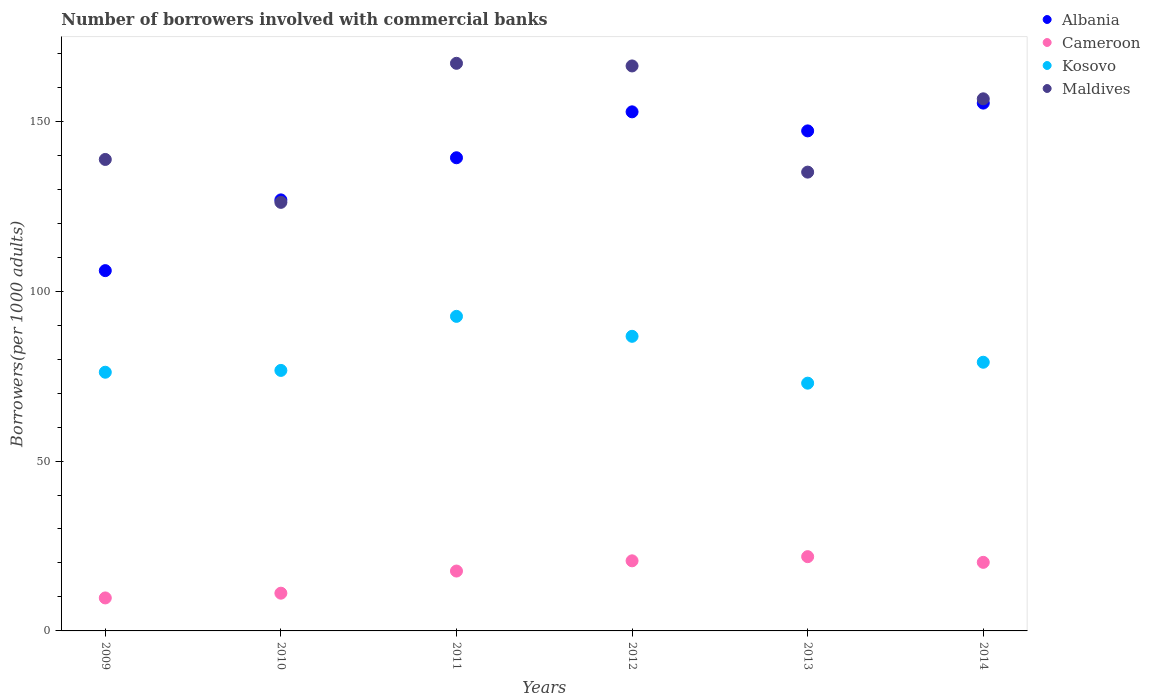Is the number of dotlines equal to the number of legend labels?
Make the answer very short. Yes. What is the number of borrowers involved with commercial banks in Kosovo in 2010?
Keep it short and to the point. 76.67. Across all years, what is the maximum number of borrowers involved with commercial banks in Kosovo?
Offer a very short reply. 92.59. Across all years, what is the minimum number of borrowers involved with commercial banks in Albania?
Keep it short and to the point. 106.05. In which year was the number of borrowers involved with commercial banks in Maldives maximum?
Keep it short and to the point. 2011. What is the total number of borrowers involved with commercial banks in Albania in the graph?
Offer a terse response. 827.49. What is the difference between the number of borrowers involved with commercial banks in Albania in 2009 and that in 2012?
Give a very brief answer. -46.73. What is the difference between the number of borrowers involved with commercial banks in Maldives in 2010 and the number of borrowers involved with commercial banks in Cameroon in 2009?
Make the answer very short. 116.43. What is the average number of borrowers involved with commercial banks in Maldives per year?
Your response must be concise. 148.32. In the year 2011, what is the difference between the number of borrowers involved with commercial banks in Albania and number of borrowers involved with commercial banks in Kosovo?
Your answer should be compact. 46.68. In how many years, is the number of borrowers involved with commercial banks in Cameroon greater than 60?
Ensure brevity in your answer.  0. What is the ratio of the number of borrowers involved with commercial banks in Kosovo in 2009 to that in 2010?
Offer a terse response. 0.99. What is the difference between the highest and the second highest number of borrowers involved with commercial banks in Cameroon?
Give a very brief answer. 1.23. What is the difference between the highest and the lowest number of borrowers involved with commercial banks in Albania?
Make the answer very short. 49.31. In how many years, is the number of borrowers involved with commercial banks in Albania greater than the average number of borrowers involved with commercial banks in Albania taken over all years?
Keep it short and to the point. 4. Is the sum of the number of borrowers involved with commercial banks in Cameroon in 2009 and 2014 greater than the maximum number of borrowers involved with commercial banks in Maldives across all years?
Your answer should be very brief. No. Is the number of borrowers involved with commercial banks in Maldives strictly less than the number of borrowers involved with commercial banks in Cameroon over the years?
Offer a terse response. No. What is the difference between two consecutive major ticks on the Y-axis?
Offer a terse response. 50. Does the graph contain grids?
Provide a succinct answer. No. Where does the legend appear in the graph?
Offer a very short reply. Top right. What is the title of the graph?
Make the answer very short. Number of borrowers involved with commercial banks. What is the label or title of the Y-axis?
Offer a very short reply. Borrowers(per 1000 adults). What is the Borrowers(per 1000 adults) in Albania in 2009?
Provide a succinct answer. 106.05. What is the Borrowers(per 1000 adults) of Cameroon in 2009?
Ensure brevity in your answer.  9.71. What is the Borrowers(per 1000 adults) in Kosovo in 2009?
Ensure brevity in your answer.  76.14. What is the Borrowers(per 1000 adults) in Maldives in 2009?
Give a very brief answer. 138.77. What is the Borrowers(per 1000 adults) of Albania in 2010?
Give a very brief answer. 126.87. What is the Borrowers(per 1000 adults) in Cameroon in 2010?
Provide a succinct answer. 11.11. What is the Borrowers(per 1000 adults) in Kosovo in 2010?
Give a very brief answer. 76.67. What is the Borrowers(per 1000 adults) in Maldives in 2010?
Provide a succinct answer. 126.14. What is the Borrowers(per 1000 adults) of Albania in 2011?
Provide a succinct answer. 139.27. What is the Borrowers(per 1000 adults) in Cameroon in 2011?
Provide a succinct answer. 17.62. What is the Borrowers(per 1000 adults) in Kosovo in 2011?
Offer a terse response. 92.59. What is the Borrowers(per 1000 adults) of Maldives in 2011?
Offer a very short reply. 167.07. What is the Borrowers(per 1000 adults) of Albania in 2012?
Your answer should be compact. 152.78. What is the Borrowers(per 1000 adults) of Cameroon in 2012?
Make the answer very short. 20.63. What is the Borrowers(per 1000 adults) in Kosovo in 2012?
Offer a very short reply. 86.71. What is the Borrowers(per 1000 adults) of Maldives in 2012?
Offer a terse response. 166.29. What is the Borrowers(per 1000 adults) of Albania in 2013?
Offer a very short reply. 147.17. What is the Borrowers(per 1000 adults) in Cameroon in 2013?
Give a very brief answer. 21.86. What is the Borrowers(per 1000 adults) in Kosovo in 2013?
Offer a terse response. 72.92. What is the Borrowers(per 1000 adults) in Maldives in 2013?
Make the answer very short. 135.04. What is the Borrowers(per 1000 adults) in Albania in 2014?
Your response must be concise. 155.35. What is the Borrowers(per 1000 adults) of Cameroon in 2014?
Your response must be concise. 20.18. What is the Borrowers(per 1000 adults) of Kosovo in 2014?
Give a very brief answer. 79.08. What is the Borrowers(per 1000 adults) in Maldives in 2014?
Offer a terse response. 156.61. Across all years, what is the maximum Borrowers(per 1000 adults) of Albania?
Offer a very short reply. 155.35. Across all years, what is the maximum Borrowers(per 1000 adults) in Cameroon?
Make the answer very short. 21.86. Across all years, what is the maximum Borrowers(per 1000 adults) of Kosovo?
Provide a short and direct response. 92.59. Across all years, what is the maximum Borrowers(per 1000 adults) of Maldives?
Keep it short and to the point. 167.07. Across all years, what is the minimum Borrowers(per 1000 adults) of Albania?
Your response must be concise. 106.05. Across all years, what is the minimum Borrowers(per 1000 adults) of Cameroon?
Offer a very short reply. 9.71. Across all years, what is the minimum Borrowers(per 1000 adults) in Kosovo?
Your response must be concise. 72.92. Across all years, what is the minimum Borrowers(per 1000 adults) of Maldives?
Make the answer very short. 126.14. What is the total Borrowers(per 1000 adults) of Albania in the graph?
Give a very brief answer. 827.49. What is the total Borrowers(per 1000 adults) of Cameroon in the graph?
Give a very brief answer. 101.11. What is the total Borrowers(per 1000 adults) in Kosovo in the graph?
Give a very brief answer. 484.12. What is the total Borrowers(per 1000 adults) in Maldives in the graph?
Give a very brief answer. 889.91. What is the difference between the Borrowers(per 1000 adults) of Albania in 2009 and that in 2010?
Provide a short and direct response. -20.82. What is the difference between the Borrowers(per 1000 adults) of Cameroon in 2009 and that in 2010?
Ensure brevity in your answer.  -1.4. What is the difference between the Borrowers(per 1000 adults) in Kosovo in 2009 and that in 2010?
Provide a short and direct response. -0.53. What is the difference between the Borrowers(per 1000 adults) in Maldives in 2009 and that in 2010?
Offer a terse response. 12.63. What is the difference between the Borrowers(per 1000 adults) of Albania in 2009 and that in 2011?
Keep it short and to the point. -33.22. What is the difference between the Borrowers(per 1000 adults) in Cameroon in 2009 and that in 2011?
Provide a succinct answer. -7.91. What is the difference between the Borrowers(per 1000 adults) in Kosovo in 2009 and that in 2011?
Provide a succinct answer. -16.44. What is the difference between the Borrowers(per 1000 adults) of Maldives in 2009 and that in 2011?
Give a very brief answer. -28.3. What is the difference between the Borrowers(per 1000 adults) in Albania in 2009 and that in 2012?
Offer a very short reply. -46.73. What is the difference between the Borrowers(per 1000 adults) in Cameroon in 2009 and that in 2012?
Give a very brief answer. -10.92. What is the difference between the Borrowers(per 1000 adults) of Kosovo in 2009 and that in 2012?
Keep it short and to the point. -10.57. What is the difference between the Borrowers(per 1000 adults) of Maldives in 2009 and that in 2012?
Offer a terse response. -27.52. What is the difference between the Borrowers(per 1000 adults) of Albania in 2009 and that in 2013?
Give a very brief answer. -41.13. What is the difference between the Borrowers(per 1000 adults) in Cameroon in 2009 and that in 2013?
Your response must be concise. -12.15. What is the difference between the Borrowers(per 1000 adults) of Kosovo in 2009 and that in 2013?
Provide a short and direct response. 3.22. What is the difference between the Borrowers(per 1000 adults) in Maldives in 2009 and that in 2013?
Offer a terse response. 3.73. What is the difference between the Borrowers(per 1000 adults) of Albania in 2009 and that in 2014?
Your answer should be compact. -49.31. What is the difference between the Borrowers(per 1000 adults) of Cameroon in 2009 and that in 2014?
Your answer should be very brief. -10.47. What is the difference between the Borrowers(per 1000 adults) of Kosovo in 2009 and that in 2014?
Make the answer very short. -2.94. What is the difference between the Borrowers(per 1000 adults) of Maldives in 2009 and that in 2014?
Your response must be concise. -17.85. What is the difference between the Borrowers(per 1000 adults) in Albania in 2010 and that in 2011?
Give a very brief answer. -12.4. What is the difference between the Borrowers(per 1000 adults) of Cameroon in 2010 and that in 2011?
Make the answer very short. -6.52. What is the difference between the Borrowers(per 1000 adults) in Kosovo in 2010 and that in 2011?
Provide a short and direct response. -15.91. What is the difference between the Borrowers(per 1000 adults) in Maldives in 2010 and that in 2011?
Offer a very short reply. -40.93. What is the difference between the Borrowers(per 1000 adults) of Albania in 2010 and that in 2012?
Your answer should be compact. -25.91. What is the difference between the Borrowers(per 1000 adults) in Cameroon in 2010 and that in 2012?
Make the answer very short. -9.53. What is the difference between the Borrowers(per 1000 adults) of Kosovo in 2010 and that in 2012?
Your answer should be very brief. -10.04. What is the difference between the Borrowers(per 1000 adults) in Maldives in 2010 and that in 2012?
Give a very brief answer. -40.15. What is the difference between the Borrowers(per 1000 adults) in Albania in 2010 and that in 2013?
Your answer should be compact. -20.31. What is the difference between the Borrowers(per 1000 adults) of Cameroon in 2010 and that in 2013?
Give a very brief answer. -10.75. What is the difference between the Borrowers(per 1000 adults) of Kosovo in 2010 and that in 2013?
Provide a short and direct response. 3.75. What is the difference between the Borrowers(per 1000 adults) in Maldives in 2010 and that in 2013?
Your answer should be compact. -8.9. What is the difference between the Borrowers(per 1000 adults) in Albania in 2010 and that in 2014?
Ensure brevity in your answer.  -28.49. What is the difference between the Borrowers(per 1000 adults) of Cameroon in 2010 and that in 2014?
Offer a very short reply. -9.08. What is the difference between the Borrowers(per 1000 adults) of Kosovo in 2010 and that in 2014?
Offer a terse response. -2.41. What is the difference between the Borrowers(per 1000 adults) in Maldives in 2010 and that in 2014?
Provide a succinct answer. -30.48. What is the difference between the Borrowers(per 1000 adults) of Albania in 2011 and that in 2012?
Your answer should be compact. -13.51. What is the difference between the Borrowers(per 1000 adults) of Cameroon in 2011 and that in 2012?
Your answer should be very brief. -3.01. What is the difference between the Borrowers(per 1000 adults) of Kosovo in 2011 and that in 2012?
Make the answer very short. 5.87. What is the difference between the Borrowers(per 1000 adults) in Maldives in 2011 and that in 2012?
Your response must be concise. 0.78. What is the difference between the Borrowers(per 1000 adults) in Albania in 2011 and that in 2013?
Provide a short and direct response. -7.91. What is the difference between the Borrowers(per 1000 adults) of Cameroon in 2011 and that in 2013?
Keep it short and to the point. -4.23. What is the difference between the Borrowers(per 1000 adults) of Kosovo in 2011 and that in 2013?
Your answer should be compact. 19.66. What is the difference between the Borrowers(per 1000 adults) of Maldives in 2011 and that in 2013?
Provide a succinct answer. 32.03. What is the difference between the Borrowers(per 1000 adults) in Albania in 2011 and that in 2014?
Offer a very short reply. -16.09. What is the difference between the Borrowers(per 1000 adults) in Cameroon in 2011 and that in 2014?
Provide a succinct answer. -2.56. What is the difference between the Borrowers(per 1000 adults) of Kosovo in 2011 and that in 2014?
Ensure brevity in your answer.  13.5. What is the difference between the Borrowers(per 1000 adults) in Maldives in 2011 and that in 2014?
Offer a very short reply. 10.45. What is the difference between the Borrowers(per 1000 adults) of Albania in 2012 and that in 2013?
Provide a succinct answer. 5.61. What is the difference between the Borrowers(per 1000 adults) in Cameroon in 2012 and that in 2013?
Offer a terse response. -1.23. What is the difference between the Borrowers(per 1000 adults) of Kosovo in 2012 and that in 2013?
Ensure brevity in your answer.  13.79. What is the difference between the Borrowers(per 1000 adults) in Maldives in 2012 and that in 2013?
Your answer should be compact. 31.25. What is the difference between the Borrowers(per 1000 adults) of Albania in 2012 and that in 2014?
Keep it short and to the point. -2.57. What is the difference between the Borrowers(per 1000 adults) of Cameroon in 2012 and that in 2014?
Offer a very short reply. 0.45. What is the difference between the Borrowers(per 1000 adults) in Kosovo in 2012 and that in 2014?
Your answer should be compact. 7.63. What is the difference between the Borrowers(per 1000 adults) in Maldives in 2012 and that in 2014?
Make the answer very short. 9.68. What is the difference between the Borrowers(per 1000 adults) of Albania in 2013 and that in 2014?
Your answer should be very brief. -8.18. What is the difference between the Borrowers(per 1000 adults) in Cameroon in 2013 and that in 2014?
Offer a terse response. 1.68. What is the difference between the Borrowers(per 1000 adults) of Kosovo in 2013 and that in 2014?
Offer a terse response. -6.16. What is the difference between the Borrowers(per 1000 adults) in Maldives in 2013 and that in 2014?
Offer a very short reply. -21.58. What is the difference between the Borrowers(per 1000 adults) in Albania in 2009 and the Borrowers(per 1000 adults) in Cameroon in 2010?
Your response must be concise. 94.94. What is the difference between the Borrowers(per 1000 adults) of Albania in 2009 and the Borrowers(per 1000 adults) of Kosovo in 2010?
Offer a very short reply. 29.37. What is the difference between the Borrowers(per 1000 adults) of Albania in 2009 and the Borrowers(per 1000 adults) of Maldives in 2010?
Offer a terse response. -20.09. What is the difference between the Borrowers(per 1000 adults) of Cameroon in 2009 and the Borrowers(per 1000 adults) of Kosovo in 2010?
Make the answer very short. -66.96. What is the difference between the Borrowers(per 1000 adults) of Cameroon in 2009 and the Borrowers(per 1000 adults) of Maldives in 2010?
Offer a very short reply. -116.43. What is the difference between the Borrowers(per 1000 adults) of Kosovo in 2009 and the Borrowers(per 1000 adults) of Maldives in 2010?
Give a very brief answer. -50. What is the difference between the Borrowers(per 1000 adults) in Albania in 2009 and the Borrowers(per 1000 adults) in Cameroon in 2011?
Offer a terse response. 88.42. What is the difference between the Borrowers(per 1000 adults) of Albania in 2009 and the Borrowers(per 1000 adults) of Kosovo in 2011?
Ensure brevity in your answer.  13.46. What is the difference between the Borrowers(per 1000 adults) in Albania in 2009 and the Borrowers(per 1000 adults) in Maldives in 2011?
Your answer should be very brief. -61.02. What is the difference between the Borrowers(per 1000 adults) of Cameroon in 2009 and the Borrowers(per 1000 adults) of Kosovo in 2011?
Your response must be concise. -82.88. What is the difference between the Borrowers(per 1000 adults) of Cameroon in 2009 and the Borrowers(per 1000 adults) of Maldives in 2011?
Your answer should be very brief. -157.36. What is the difference between the Borrowers(per 1000 adults) of Kosovo in 2009 and the Borrowers(per 1000 adults) of Maldives in 2011?
Offer a very short reply. -90.93. What is the difference between the Borrowers(per 1000 adults) in Albania in 2009 and the Borrowers(per 1000 adults) in Cameroon in 2012?
Offer a terse response. 85.42. What is the difference between the Borrowers(per 1000 adults) in Albania in 2009 and the Borrowers(per 1000 adults) in Kosovo in 2012?
Your answer should be very brief. 19.33. What is the difference between the Borrowers(per 1000 adults) of Albania in 2009 and the Borrowers(per 1000 adults) of Maldives in 2012?
Offer a very short reply. -60.24. What is the difference between the Borrowers(per 1000 adults) in Cameroon in 2009 and the Borrowers(per 1000 adults) in Kosovo in 2012?
Ensure brevity in your answer.  -77. What is the difference between the Borrowers(per 1000 adults) in Cameroon in 2009 and the Borrowers(per 1000 adults) in Maldives in 2012?
Provide a short and direct response. -156.58. What is the difference between the Borrowers(per 1000 adults) of Kosovo in 2009 and the Borrowers(per 1000 adults) of Maldives in 2012?
Offer a very short reply. -90.15. What is the difference between the Borrowers(per 1000 adults) in Albania in 2009 and the Borrowers(per 1000 adults) in Cameroon in 2013?
Ensure brevity in your answer.  84.19. What is the difference between the Borrowers(per 1000 adults) in Albania in 2009 and the Borrowers(per 1000 adults) in Kosovo in 2013?
Your answer should be very brief. 33.12. What is the difference between the Borrowers(per 1000 adults) of Albania in 2009 and the Borrowers(per 1000 adults) of Maldives in 2013?
Your answer should be very brief. -28.99. What is the difference between the Borrowers(per 1000 adults) of Cameroon in 2009 and the Borrowers(per 1000 adults) of Kosovo in 2013?
Ensure brevity in your answer.  -63.21. What is the difference between the Borrowers(per 1000 adults) of Cameroon in 2009 and the Borrowers(per 1000 adults) of Maldives in 2013?
Your answer should be very brief. -125.33. What is the difference between the Borrowers(per 1000 adults) of Kosovo in 2009 and the Borrowers(per 1000 adults) of Maldives in 2013?
Your answer should be compact. -58.9. What is the difference between the Borrowers(per 1000 adults) in Albania in 2009 and the Borrowers(per 1000 adults) in Cameroon in 2014?
Offer a very short reply. 85.86. What is the difference between the Borrowers(per 1000 adults) of Albania in 2009 and the Borrowers(per 1000 adults) of Kosovo in 2014?
Offer a very short reply. 26.96. What is the difference between the Borrowers(per 1000 adults) in Albania in 2009 and the Borrowers(per 1000 adults) in Maldives in 2014?
Your answer should be compact. -50.57. What is the difference between the Borrowers(per 1000 adults) of Cameroon in 2009 and the Borrowers(per 1000 adults) of Kosovo in 2014?
Your answer should be very brief. -69.37. What is the difference between the Borrowers(per 1000 adults) in Cameroon in 2009 and the Borrowers(per 1000 adults) in Maldives in 2014?
Ensure brevity in your answer.  -146.9. What is the difference between the Borrowers(per 1000 adults) of Kosovo in 2009 and the Borrowers(per 1000 adults) of Maldives in 2014?
Make the answer very short. -80.47. What is the difference between the Borrowers(per 1000 adults) of Albania in 2010 and the Borrowers(per 1000 adults) of Cameroon in 2011?
Give a very brief answer. 109.24. What is the difference between the Borrowers(per 1000 adults) of Albania in 2010 and the Borrowers(per 1000 adults) of Kosovo in 2011?
Keep it short and to the point. 34.28. What is the difference between the Borrowers(per 1000 adults) of Albania in 2010 and the Borrowers(per 1000 adults) of Maldives in 2011?
Offer a terse response. -40.2. What is the difference between the Borrowers(per 1000 adults) in Cameroon in 2010 and the Borrowers(per 1000 adults) in Kosovo in 2011?
Offer a terse response. -81.48. What is the difference between the Borrowers(per 1000 adults) of Cameroon in 2010 and the Borrowers(per 1000 adults) of Maldives in 2011?
Make the answer very short. -155.96. What is the difference between the Borrowers(per 1000 adults) in Kosovo in 2010 and the Borrowers(per 1000 adults) in Maldives in 2011?
Make the answer very short. -90.39. What is the difference between the Borrowers(per 1000 adults) of Albania in 2010 and the Borrowers(per 1000 adults) of Cameroon in 2012?
Your answer should be compact. 106.24. What is the difference between the Borrowers(per 1000 adults) in Albania in 2010 and the Borrowers(per 1000 adults) in Kosovo in 2012?
Make the answer very short. 40.16. What is the difference between the Borrowers(per 1000 adults) in Albania in 2010 and the Borrowers(per 1000 adults) in Maldives in 2012?
Keep it short and to the point. -39.42. What is the difference between the Borrowers(per 1000 adults) of Cameroon in 2010 and the Borrowers(per 1000 adults) of Kosovo in 2012?
Offer a very short reply. -75.61. What is the difference between the Borrowers(per 1000 adults) of Cameroon in 2010 and the Borrowers(per 1000 adults) of Maldives in 2012?
Make the answer very short. -155.18. What is the difference between the Borrowers(per 1000 adults) in Kosovo in 2010 and the Borrowers(per 1000 adults) in Maldives in 2012?
Keep it short and to the point. -89.62. What is the difference between the Borrowers(per 1000 adults) of Albania in 2010 and the Borrowers(per 1000 adults) of Cameroon in 2013?
Ensure brevity in your answer.  105.01. What is the difference between the Borrowers(per 1000 adults) of Albania in 2010 and the Borrowers(per 1000 adults) of Kosovo in 2013?
Keep it short and to the point. 53.95. What is the difference between the Borrowers(per 1000 adults) in Albania in 2010 and the Borrowers(per 1000 adults) in Maldives in 2013?
Provide a succinct answer. -8.17. What is the difference between the Borrowers(per 1000 adults) of Cameroon in 2010 and the Borrowers(per 1000 adults) of Kosovo in 2013?
Make the answer very short. -61.82. What is the difference between the Borrowers(per 1000 adults) of Cameroon in 2010 and the Borrowers(per 1000 adults) of Maldives in 2013?
Offer a very short reply. -123.93. What is the difference between the Borrowers(per 1000 adults) in Kosovo in 2010 and the Borrowers(per 1000 adults) in Maldives in 2013?
Make the answer very short. -58.36. What is the difference between the Borrowers(per 1000 adults) of Albania in 2010 and the Borrowers(per 1000 adults) of Cameroon in 2014?
Your answer should be very brief. 106.69. What is the difference between the Borrowers(per 1000 adults) in Albania in 2010 and the Borrowers(per 1000 adults) in Kosovo in 2014?
Ensure brevity in your answer.  47.79. What is the difference between the Borrowers(per 1000 adults) in Albania in 2010 and the Borrowers(per 1000 adults) in Maldives in 2014?
Make the answer very short. -29.75. What is the difference between the Borrowers(per 1000 adults) of Cameroon in 2010 and the Borrowers(per 1000 adults) of Kosovo in 2014?
Make the answer very short. -67.98. What is the difference between the Borrowers(per 1000 adults) of Cameroon in 2010 and the Borrowers(per 1000 adults) of Maldives in 2014?
Provide a short and direct response. -145.51. What is the difference between the Borrowers(per 1000 adults) in Kosovo in 2010 and the Borrowers(per 1000 adults) in Maldives in 2014?
Give a very brief answer. -79.94. What is the difference between the Borrowers(per 1000 adults) of Albania in 2011 and the Borrowers(per 1000 adults) of Cameroon in 2012?
Make the answer very short. 118.64. What is the difference between the Borrowers(per 1000 adults) in Albania in 2011 and the Borrowers(per 1000 adults) in Kosovo in 2012?
Ensure brevity in your answer.  52.55. What is the difference between the Borrowers(per 1000 adults) in Albania in 2011 and the Borrowers(per 1000 adults) in Maldives in 2012?
Provide a short and direct response. -27.02. What is the difference between the Borrowers(per 1000 adults) in Cameroon in 2011 and the Borrowers(per 1000 adults) in Kosovo in 2012?
Give a very brief answer. -69.09. What is the difference between the Borrowers(per 1000 adults) of Cameroon in 2011 and the Borrowers(per 1000 adults) of Maldives in 2012?
Provide a short and direct response. -148.67. What is the difference between the Borrowers(per 1000 adults) of Kosovo in 2011 and the Borrowers(per 1000 adults) of Maldives in 2012?
Make the answer very short. -73.7. What is the difference between the Borrowers(per 1000 adults) in Albania in 2011 and the Borrowers(per 1000 adults) in Cameroon in 2013?
Keep it short and to the point. 117.41. What is the difference between the Borrowers(per 1000 adults) of Albania in 2011 and the Borrowers(per 1000 adults) of Kosovo in 2013?
Offer a very short reply. 66.34. What is the difference between the Borrowers(per 1000 adults) in Albania in 2011 and the Borrowers(per 1000 adults) in Maldives in 2013?
Offer a terse response. 4.23. What is the difference between the Borrowers(per 1000 adults) of Cameroon in 2011 and the Borrowers(per 1000 adults) of Kosovo in 2013?
Offer a very short reply. -55.3. What is the difference between the Borrowers(per 1000 adults) of Cameroon in 2011 and the Borrowers(per 1000 adults) of Maldives in 2013?
Ensure brevity in your answer.  -117.41. What is the difference between the Borrowers(per 1000 adults) of Kosovo in 2011 and the Borrowers(per 1000 adults) of Maldives in 2013?
Provide a short and direct response. -42.45. What is the difference between the Borrowers(per 1000 adults) of Albania in 2011 and the Borrowers(per 1000 adults) of Cameroon in 2014?
Your answer should be compact. 119.08. What is the difference between the Borrowers(per 1000 adults) in Albania in 2011 and the Borrowers(per 1000 adults) in Kosovo in 2014?
Give a very brief answer. 60.19. What is the difference between the Borrowers(per 1000 adults) of Albania in 2011 and the Borrowers(per 1000 adults) of Maldives in 2014?
Make the answer very short. -17.35. What is the difference between the Borrowers(per 1000 adults) in Cameroon in 2011 and the Borrowers(per 1000 adults) in Kosovo in 2014?
Your answer should be compact. -61.46. What is the difference between the Borrowers(per 1000 adults) in Cameroon in 2011 and the Borrowers(per 1000 adults) in Maldives in 2014?
Make the answer very short. -138.99. What is the difference between the Borrowers(per 1000 adults) of Kosovo in 2011 and the Borrowers(per 1000 adults) of Maldives in 2014?
Make the answer very short. -64.03. What is the difference between the Borrowers(per 1000 adults) of Albania in 2012 and the Borrowers(per 1000 adults) of Cameroon in 2013?
Keep it short and to the point. 130.92. What is the difference between the Borrowers(per 1000 adults) of Albania in 2012 and the Borrowers(per 1000 adults) of Kosovo in 2013?
Offer a very short reply. 79.86. What is the difference between the Borrowers(per 1000 adults) of Albania in 2012 and the Borrowers(per 1000 adults) of Maldives in 2013?
Offer a very short reply. 17.74. What is the difference between the Borrowers(per 1000 adults) of Cameroon in 2012 and the Borrowers(per 1000 adults) of Kosovo in 2013?
Offer a very short reply. -52.29. What is the difference between the Borrowers(per 1000 adults) of Cameroon in 2012 and the Borrowers(per 1000 adults) of Maldives in 2013?
Provide a short and direct response. -114.41. What is the difference between the Borrowers(per 1000 adults) in Kosovo in 2012 and the Borrowers(per 1000 adults) in Maldives in 2013?
Ensure brevity in your answer.  -48.33. What is the difference between the Borrowers(per 1000 adults) of Albania in 2012 and the Borrowers(per 1000 adults) of Cameroon in 2014?
Your answer should be very brief. 132.6. What is the difference between the Borrowers(per 1000 adults) of Albania in 2012 and the Borrowers(per 1000 adults) of Kosovo in 2014?
Keep it short and to the point. 73.7. What is the difference between the Borrowers(per 1000 adults) of Albania in 2012 and the Borrowers(per 1000 adults) of Maldives in 2014?
Provide a short and direct response. -3.83. What is the difference between the Borrowers(per 1000 adults) in Cameroon in 2012 and the Borrowers(per 1000 adults) in Kosovo in 2014?
Provide a short and direct response. -58.45. What is the difference between the Borrowers(per 1000 adults) in Cameroon in 2012 and the Borrowers(per 1000 adults) in Maldives in 2014?
Keep it short and to the point. -135.98. What is the difference between the Borrowers(per 1000 adults) of Kosovo in 2012 and the Borrowers(per 1000 adults) of Maldives in 2014?
Offer a terse response. -69.9. What is the difference between the Borrowers(per 1000 adults) of Albania in 2013 and the Borrowers(per 1000 adults) of Cameroon in 2014?
Your answer should be very brief. 126.99. What is the difference between the Borrowers(per 1000 adults) of Albania in 2013 and the Borrowers(per 1000 adults) of Kosovo in 2014?
Your response must be concise. 68.09. What is the difference between the Borrowers(per 1000 adults) in Albania in 2013 and the Borrowers(per 1000 adults) in Maldives in 2014?
Offer a very short reply. -9.44. What is the difference between the Borrowers(per 1000 adults) in Cameroon in 2013 and the Borrowers(per 1000 adults) in Kosovo in 2014?
Offer a terse response. -57.22. What is the difference between the Borrowers(per 1000 adults) in Cameroon in 2013 and the Borrowers(per 1000 adults) in Maldives in 2014?
Keep it short and to the point. -134.76. What is the difference between the Borrowers(per 1000 adults) in Kosovo in 2013 and the Borrowers(per 1000 adults) in Maldives in 2014?
Keep it short and to the point. -83.69. What is the average Borrowers(per 1000 adults) of Albania per year?
Keep it short and to the point. 137.91. What is the average Borrowers(per 1000 adults) in Cameroon per year?
Your response must be concise. 16.85. What is the average Borrowers(per 1000 adults) in Kosovo per year?
Give a very brief answer. 80.69. What is the average Borrowers(per 1000 adults) in Maldives per year?
Keep it short and to the point. 148.32. In the year 2009, what is the difference between the Borrowers(per 1000 adults) of Albania and Borrowers(per 1000 adults) of Cameroon?
Give a very brief answer. 96.34. In the year 2009, what is the difference between the Borrowers(per 1000 adults) of Albania and Borrowers(per 1000 adults) of Kosovo?
Your response must be concise. 29.91. In the year 2009, what is the difference between the Borrowers(per 1000 adults) of Albania and Borrowers(per 1000 adults) of Maldives?
Your answer should be very brief. -32.72. In the year 2009, what is the difference between the Borrowers(per 1000 adults) in Cameroon and Borrowers(per 1000 adults) in Kosovo?
Ensure brevity in your answer.  -66.43. In the year 2009, what is the difference between the Borrowers(per 1000 adults) in Cameroon and Borrowers(per 1000 adults) in Maldives?
Your answer should be very brief. -129.06. In the year 2009, what is the difference between the Borrowers(per 1000 adults) of Kosovo and Borrowers(per 1000 adults) of Maldives?
Provide a short and direct response. -62.63. In the year 2010, what is the difference between the Borrowers(per 1000 adults) of Albania and Borrowers(per 1000 adults) of Cameroon?
Keep it short and to the point. 115.76. In the year 2010, what is the difference between the Borrowers(per 1000 adults) in Albania and Borrowers(per 1000 adults) in Kosovo?
Ensure brevity in your answer.  50.19. In the year 2010, what is the difference between the Borrowers(per 1000 adults) in Albania and Borrowers(per 1000 adults) in Maldives?
Your answer should be compact. 0.73. In the year 2010, what is the difference between the Borrowers(per 1000 adults) in Cameroon and Borrowers(per 1000 adults) in Kosovo?
Your response must be concise. -65.57. In the year 2010, what is the difference between the Borrowers(per 1000 adults) of Cameroon and Borrowers(per 1000 adults) of Maldives?
Offer a terse response. -115.03. In the year 2010, what is the difference between the Borrowers(per 1000 adults) of Kosovo and Borrowers(per 1000 adults) of Maldives?
Give a very brief answer. -49.46. In the year 2011, what is the difference between the Borrowers(per 1000 adults) of Albania and Borrowers(per 1000 adults) of Cameroon?
Offer a very short reply. 121.64. In the year 2011, what is the difference between the Borrowers(per 1000 adults) of Albania and Borrowers(per 1000 adults) of Kosovo?
Make the answer very short. 46.68. In the year 2011, what is the difference between the Borrowers(per 1000 adults) of Albania and Borrowers(per 1000 adults) of Maldives?
Your answer should be very brief. -27.8. In the year 2011, what is the difference between the Borrowers(per 1000 adults) in Cameroon and Borrowers(per 1000 adults) in Kosovo?
Offer a terse response. -74.96. In the year 2011, what is the difference between the Borrowers(per 1000 adults) in Cameroon and Borrowers(per 1000 adults) in Maldives?
Offer a very short reply. -149.44. In the year 2011, what is the difference between the Borrowers(per 1000 adults) of Kosovo and Borrowers(per 1000 adults) of Maldives?
Offer a terse response. -74.48. In the year 2012, what is the difference between the Borrowers(per 1000 adults) of Albania and Borrowers(per 1000 adults) of Cameroon?
Offer a terse response. 132.15. In the year 2012, what is the difference between the Borrowers(per 1000 adults) of Albania and Borrowers(per 1000 adults) of Kosovo?
Provide a short and direct response. 66.07. In the year 2012, what is the difference between the Borrowers(per 1000 adults) of Albania and Borrowers(per 1000 adults) of Maldives?
Offer a terse response. -13.51. In the year 2012, what is the difference between the Borrowers(per 1000 adults) of Cameroon and Borrowers(per 1000 adults) of Kosovo?
Your answer should be compact. -66.08. In the year 2012, what is the difference between the Borrowers(per 1000 adults) in Cameroon and Borrowers(per 1000 adults) in Maldives?
Provide a succinct answer. -145.66. In the year 2012, what is the difference between the Borrowers(per 1000 adults) of Kosovo and Borrowers(per 1000 adults) of Maldives?
Offer a terse response. -79.58. In the year 2013, what is the difference between the Borrowers(per 1000 adults) of Albania and Borrowers(per 1000 adults) of Cameroon?
Your answer should be very brief. 125.32. In the year 2013, what is the difference between the Borrowers(per 1000 adults) in Albania and Borrowers(per 1000 adults) in Kosovo?
Provide a succinct answer. 74.25. In the year 2013, what is the difference between the Borrowers(per 1000 adults) of Albania and Borrowers(per 1000 adults) of Maldives?
Make the answer very short. 12.14. In the year 2013, what is the difference between the Borrowers(per 1000 adults) of Cameroon and Borrowers(per 1000 adults) of Kosovo?
Make the answer very short. -51.06. In the year 2013, what is the difference between the Borrowers(per 1000 adults) of Cameroon and Borrowers(per 1000 adults) of Maldives?
Make the answer very short. -113.18. In the year 2013, what is the difference between the Borrowers(per 1000 adults) of Kosovo and Borrowers(per 1000 adults) of Maldives?
Give a very brief answer. -62.12. In the year 2014, what is the difference between the Borrowers(per 1000 adults) of Albania and Borrowers(per 1000 adults) of Cameroon?
Offer a very short reply. 135.17. In the year 2014, what is the difference between the Borrowers(per 1000 adults) of Albania and Borrowers(per 1000 adults) of Kosovo?
Your answer should be compact. 76.27. In the year 2014, what is the difference between the Borrowers(per 1000 adults) in Albania and Borrowers(per 1000 adults) in Maldives?
Offer a terse response. -1.26. In the year 2014, what is the difference between the Borrowers(per 1000 adults) of Cameroon and Borrowers(per 1000 adults) of Kosovo?
Ensure brevity in your answer.  -58.9. In the year 2014, what is the difference between the Borrowers(per 1000 adults) in Cameroon and Borrowers(per 1000 adults) in Maldives?
Ensure brevity in your answer.  -136.43. In the year 2014, what is the difference between the Borrowers(per 1000 adults) in Kosovo and Borrowers(per 1000 adults) in Maldives?
Offer a very short reply. -77.53. What is the ratio of the Borrowers(per 1000 adults) in Albania in 2009 to that in 2010?
Provide a short and direct response. 0.84. What is the ratio of the Borrowers(per 1000 adults) of Cameroon in 2009 to that in 2010?
Your answer should be compact. 0.87. What is the ratio of the Borrowers(per 1000 adults) of Maldives in 2009 to that in 2010?
Your response must be concise. 1.1. What is the ratio of the Borrowers(per 1000 adults) of Albania in 2009 to that in 2011?
Provide a short and direct response. 0.76. What is the ratio of the Borrowers(per 1000 adults) in Cameroon in 2009 to that in 2011?
Ensure brevity in your answer.  0.55. What is the ratio of the Borrowers(per 1000 adults) in Kosovo in 2009 to that in 2011?
Provide a succinct answer. 0.82. What is the ratio of the Borrowers(per 1000 adults) of Maldives in 2009 to that in 2011?
Your response must be concise. 0.83. What is the ratio of the Borrowers(per 1000 adults) of Albania in 2009 to that in 2012?
Your answer should be very brief. 0.69. What is the ratio of the Borrowers(per 1000 adults) in Cameroon in 2009 to that in 2012?
Offer a very short reply. 0.47. What is the ratio of the Borrowers(per 1000 adults) of Kosovo in 2009 to that in 2012?
Provide a short and direct response. 0.88. What is the ratio of the Borrowers(per 1000 adults) of Maldives in 2009 to that in 2012?
Make the answer very short. 0.83. What is the ratio of the Borrowers(per 1000 adults) in Albania in 2009 to that in 2013?
Provide a succinct answer. 0.72. What is the ratio of the Borrowers(per 1000 adults) in Cameroon in 2009 to that in 2013?
Provide a short and direct response. 0.44. What is the ratio of the Borrowers(per 1000 adults) of Kosovo in 2009 to that in 2013?
Provide a short and direct response. 1.04. What is the ratio of the Borrowers(per 1000 adults) in Maldives in 2009 to that in 2013?
Make the answer very short. 1.03. What is the ratio of the Borrowers(per 1000 adults) in Albania in 2009 to that in 2014?
Your answer should be very brief. 0.68. What is the ratio of the Borrowers(per 1000 adults) in Cameroon in 2009 to that in 2014?
Keep it short and to the point. 0.48. What is the ratio of the Borrowers(per 1000 adults) of Kosovo in 2009 to that in 2014?
Ensure brevity in your answer.  0.96. What is the ratio of the Borrowers(per 1000 adults) of Maldives in 2009 to that in 2014?
Your answer should be very brief. 0.89. What is the ratio of the Borrowers(per 1000 adults) of Albania in 2010 to that in 2011?
Your answer should be compact. 0.91. What is the ratio of the Borrowers(per 1000 adults) in Cameroon in 2010 to that in 2011?
Provide a succinct answer. 0.63. What is the ratio of the Borrowers(per 1000 adults) of Kosovo in 2010 to that in 2011?
Ensure brevity in your answer.  0.83. What is the ratio of the Borrowers(per 1000 adults) of Maldives in 2010 to that in 2011?
Provide a succinct answer. 0.76. What is the ratio of the Borrowers(per 1000 adults) in Albania in 2010 to that in 2012?
Keep it short and to the point. 0.83. What is the ratio of the Borrowers(per 1000 adults) of Cameroon in 2010 to that in 2012?
Your response must be concise. 0.54. What is the ratio of the Borrowers(per 1000 adults) of Kosovo in 2010 to that in 2012?
Your response must be concise. 0.88. What is the ratio of the Borrowers(per 1000 adults) in Maldives in 2010 to that in 2012?
Offer a very short reply. 0.76. What is the ratio of the Borrowers(per 1000 adults) in Albania in 2010 to that in 2013?
Give a very brief answer. 0.86. What is the ratio of the Borrowers(per 1000 adults) in Cameroon in 2010 to that in 2013?
Your answer should be compact. 0.51. What is the ratio of the Borrowers(per 1000 adults) of Kosovo in 2010 to that in 2013?
Give a very brief answer. 1.05. What is the ratio of the Borrowers(per 1000 adults) of Maldives in 2010 to that in 2013?
Ensure brevity in your answer.  0.93. What is the ratio of the Borrowers(per 1000 adults) of Albania in 2010 to that in 2014?
Provide a succinct answer. 0.82. What is the ratio of the Borrowers(per 1000 adults) of Cameroon in 2010 to that in 2014?
Make the answer very short. 0.55. What is the ratio of the Borrowers(per 1000 adults) in Kosovo in 2010 to that in 2014?
Ensure brevity in your answer.  0.97. What is the ratio of the Borrowers(per 1000 adults) of Maldives in 2010 to that in 2014?
Ensure brevity in your answer.  0.81. What is the ratio of the Borrowers(per 1000 adults) of Albania in 2011 to that in 2012?
Give a very brief answer. 0.91. What is the ratio of the Borrowers(per 1000 adults) of Cameroon in 2011 to that in 2012?
Your response must be concise. 0.85. What is the ratio of the Borrowers(per 1000 adults) of Kosovo in 2011 to that in 2012?
Keep it short and to the point. 1.07. What is the ratio of the Borrowers(per 1000 adults) of Albania in 2011 to that in 2013?
Provide a short and direct response. 0.95. What is the ratio of the Borrowers(per 1000 adults) of Cameroon in 2011 to that in 2013?
Provide a short and direct response. 0.81. What is the ratio of the Borrowers(per 1000 adults) of Kosovo in 2011 to that in 2013?
Ensure brevity in your answer.  1.27. What is the ratio of the Borrowers(per 1000 adults) of Maldives in 2011 to that in 2013?
Ensure brevity in your answer.  1.24. What is the ratio of the Borrowers(per 1000 adults) of Albania in 2011 to that in 2014?
Provide a succinct answer. 0.9. What is the ratio of the Borrowers(per 1000 adults) in Cameroon in 2011 to that in 2014?
Your response must be concise. 0.87. What is the ratio of the Borrowers(per 1000 adults) in Kosovo in 2011 to that in 2014?
Your answer should be very brief. 1.17. What is the ratio of the Borrowers(per 1000 adults) in Maldives in 2011 to that in 2014?
Offer a terse response. 1.07. What is the ratio of the Borrowers(per 1000 adults) in Albania in 2012 to that in 2013?
Provide a short and direct response. 1.04. What is the ratio of the Borrowers(per 1000 adults) of Cameroon in 2012 to that in 2013?
Give a very brief answer. 0.94. What is the ratio of the Borrowers(per 1000 adults) of Kosovo in 2012 to that in 2013?
Make the answer very short. 1.19. What is the ratio of the Borrowers(per 1000 adults) of Maldives in 2012 to that in 2013?
Make the answer very short. 1.23. What is the ratio of the Borrowers(per 1000 adults) in Albania in 2012 to that in 2014?
Provide a succinct answer. 0.98. What is the ratio of the Borrowers(per 1000 adults) in Cameroon in 2012 to that in 2014?
Provide a succinct answer. 1.02. What is the ratio of the Borrowers(per 1000 adults) in Kosovo in 2012 to that in 2014?
Give a very brief answer. 1.1. What is the ratio of the Borrowers(per 1000 adults) of Maldives in 2012 to that in 2014?
Offer a very short reply. 1.06. What is the ratio of the Borrowers(per 1000 adults) of Albania in 2013 to that in 2014?
Offer a very short reply. 0.95. What is the ratio of the Borrowers(per 1000 adults) of Cameroon in 2013 to that in 2014?
Give a very brief answer. 1.08. What is the ratio of the Borrowers(per 1000 adults) of Kosovo in 2013 to that in 2014?
Offer a terse response. 0.92. What is the ratio of the Borrowers(per 1000 adults) in Maldives in 2013 to that in 2014?
Make the answer very short. 0.86. What is the difference between the highest and the second highest Borrowers(per 1000 adults) in Albania?
Your answer should be compact. 2.57. What is the difference between the highest and the second highest Borrowers(per 1000 adults) of Cameroon?
Ensure brevity in your answer.  1.23. What is the difference between the highest and the second highest Borrowers(per 1000 adults) in Kosovo?
Give a very brief answer. 5.87. What is the difference between the highest and the second highest Borrowers(per 1000 adults) in Maldives?
Your answer should be compact. 0.78. What is the difference between the highest and the lowest Borrowers(per 1000 adults) in Albania?
Your answer should be very brief. 49.31. What is the difference between the highest and the lowest Borrowers(per 1000 adults) of Cameroon?
Make the answer very short. 12.15. What is the difference between the highest and the lowest Borrowers(per 1000 adults) in Kosovo?
Provide a succinct answer. 19.66. What is the difference between the highest and the lowest Borrowers(per 1000 adults) in Maldives?
Your response must be concise. 40.93. 